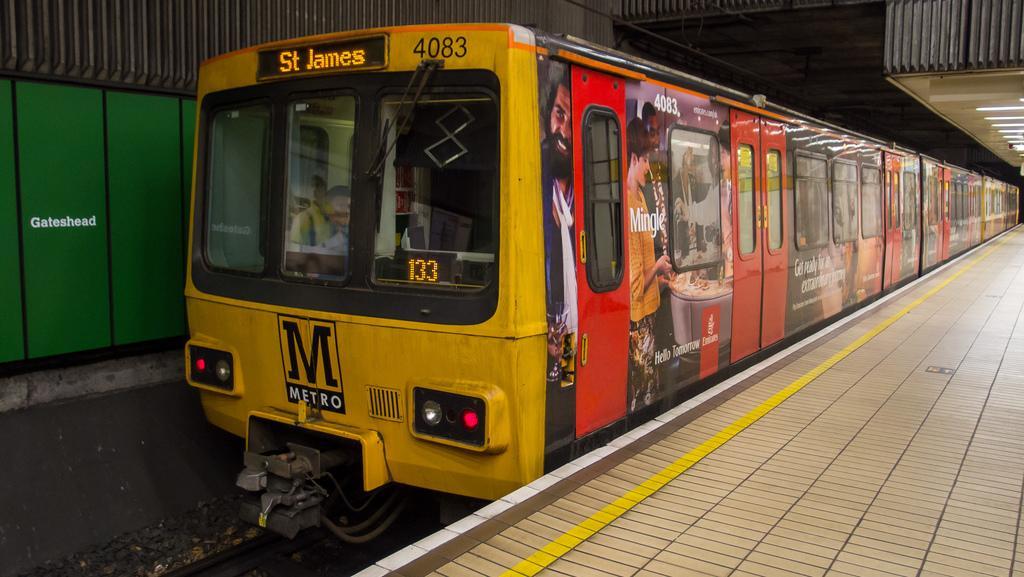Please provide a concise description of this image. In this image we can see a locomotive which is of yellow color is on the platform and at the top of the image there is roof which is made of iron sheet. 